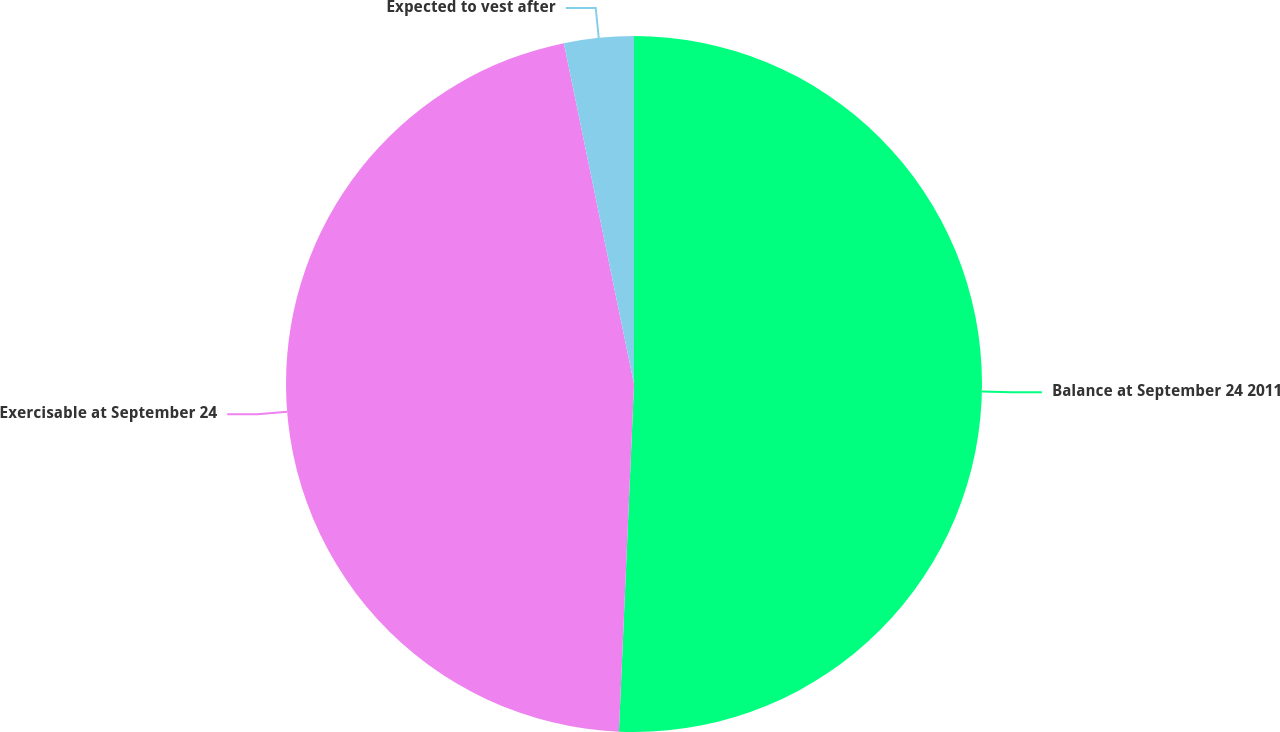<chart> <loc_0><loc_0><loc_500><loc_500><pie_chart><fcel>Balance at September 24 2011<fcel>Exercisable at September 24<fcel>Expected to vest after<nl><fcel>50.69%<fcel>46.08%<fcel>3.23%<nl></chart> 